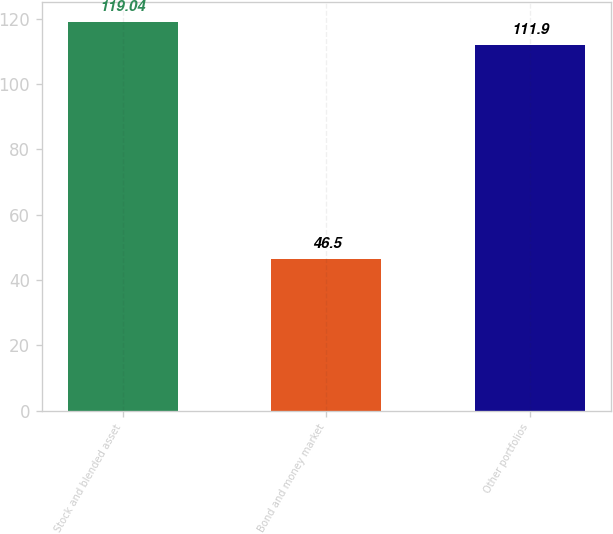Convert chart. <chart><loc_0><loc_0><loc_500><loc_500><bar_chart><fcel>Stock and blended asset<fcel>Bond and money market<fcel>Other portfolios<nl><fcel>119.04<fcel>46.5<fcel>111.9<nl></chart> 